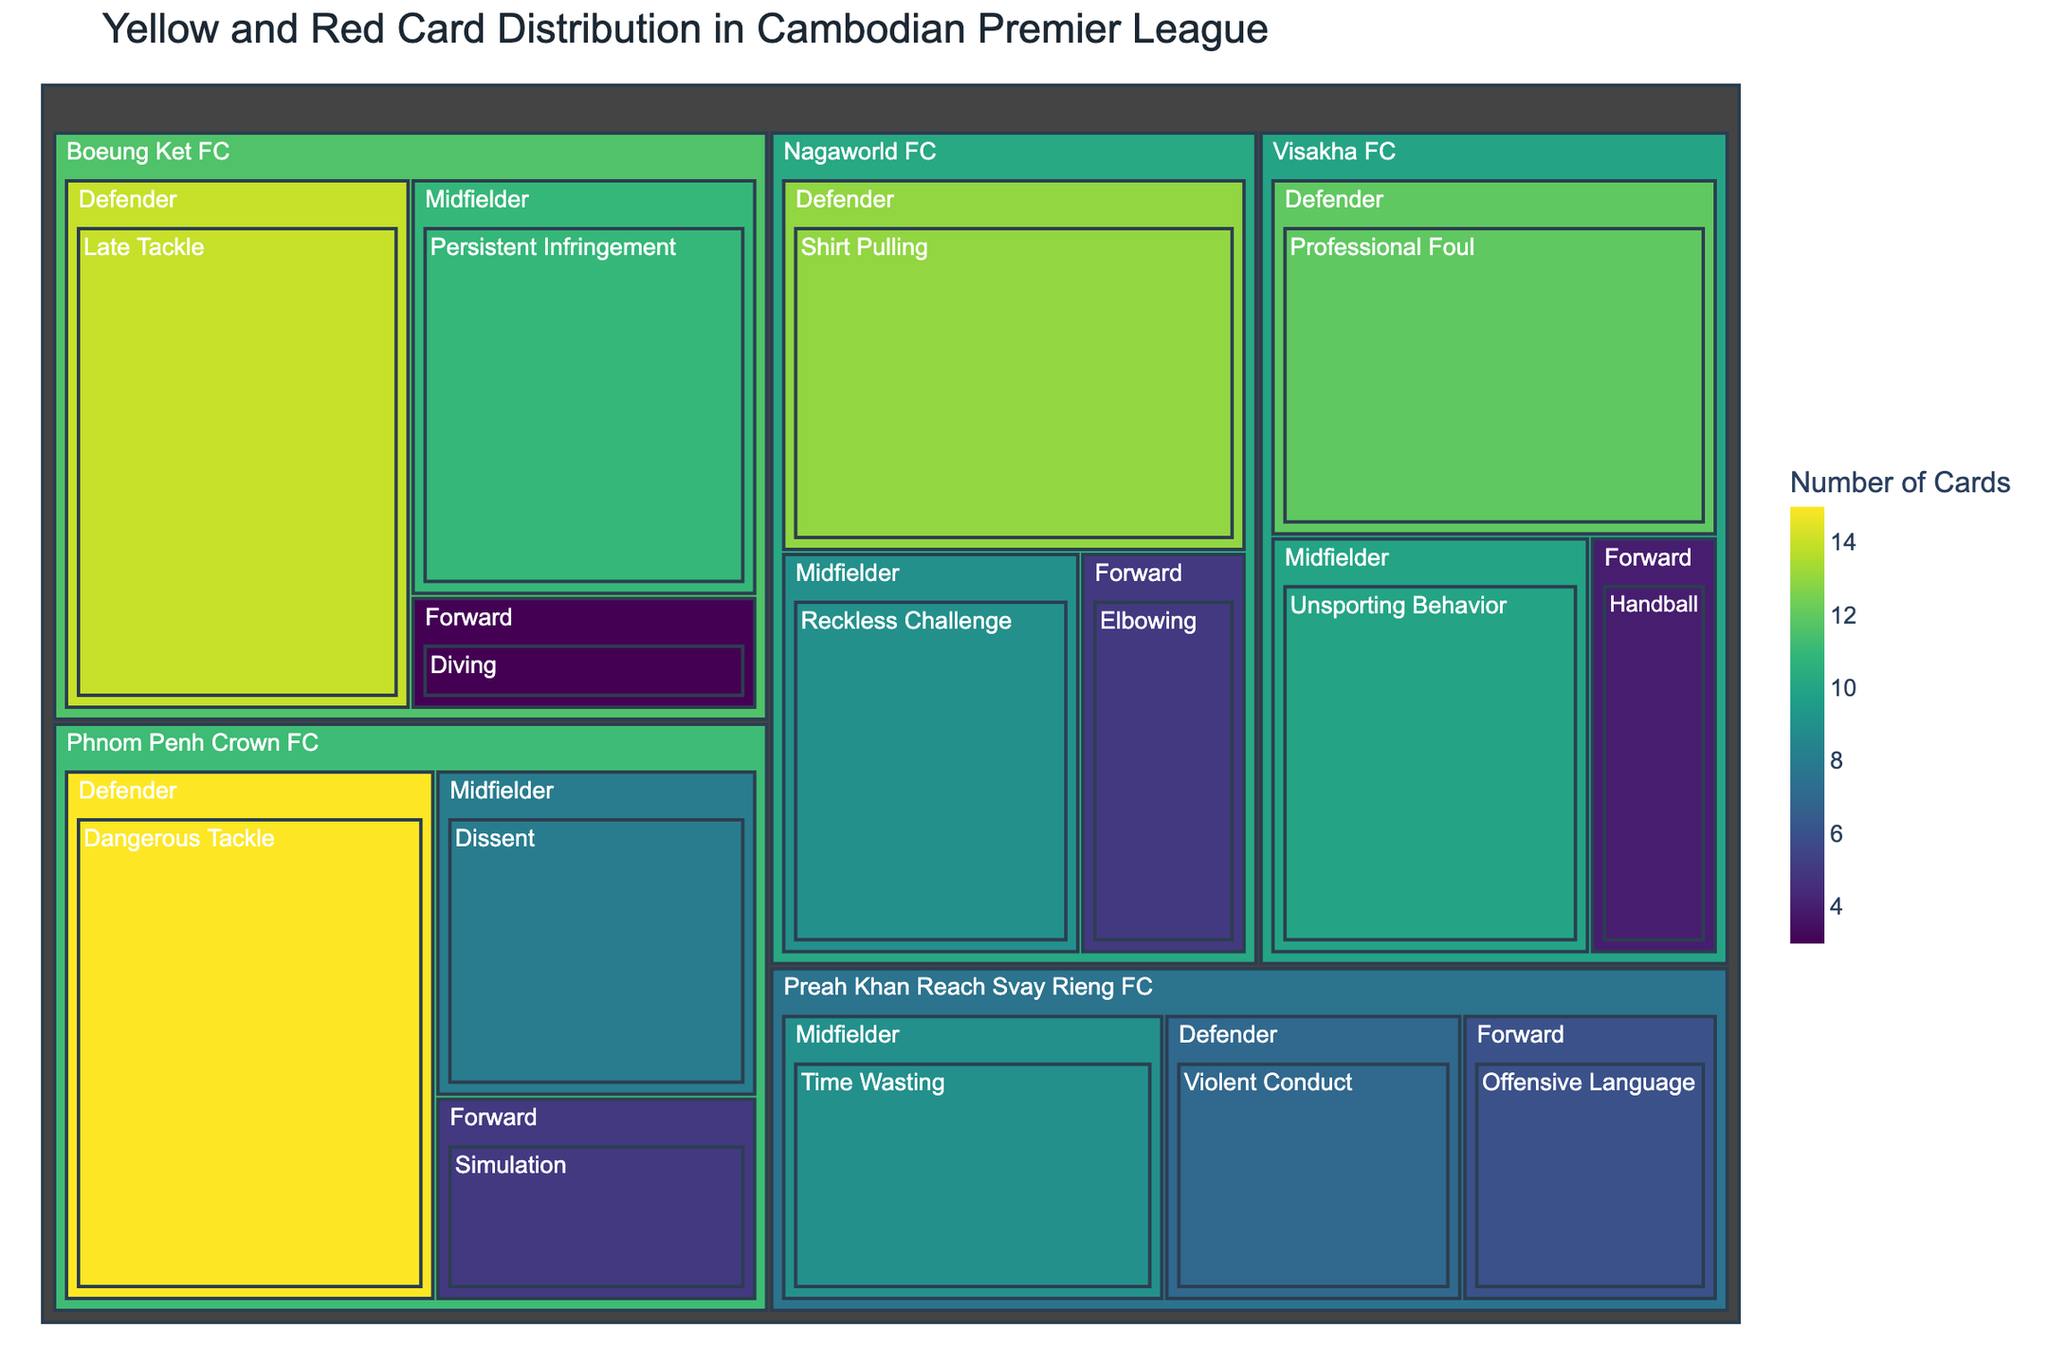What's the title of the figure? Look at the top of the treemap where the title is usually placed in bold or larger font.
Answer: Yellow and Red Card Distribution in Cambodian Premier League Which team has the highest number of cards for a single foul type? Identify the largest tile under each team's section and compare their sizes.
Answer: Phnom Penh Crown FC (Dangerous Tackle) How many cards were given to forwards for Phnom Penh Crown FC? Locate the section under Phnom Penh Crown FC for forwards and sum the values of the tiles.
Answer: 5 Which team has the least number of cards for handball? Examine each team's section to find any occurrence of handball and compare the values.
Answer: Visakha FC Compare the total number of cards for defenders versus midfielders in Boeung Ket FC. Add up the card values for defenders and midfielders under Boeung Ket FC.
Answer: Defenders: 14, Midfielders: 11 What is the average number of cards given to midfielders across all teams? Sum up all the cards given to midfielders and divide by the number of teams.
Answer: (8 + 10 + 9 + 11 + 9) / 5 = 47/5 = 9.4 Which foul type committed by defenders has the highest card count? Look under the defenders' category for each team and find the foul type with the largest card count.
Answer: Dangerous Tackle (15 cards) How do the total cards for dangerous tackles compare to those for dissent? Find the total card count for dangerous tackles and compare it with that for dissent.
Answer: Dangerous Tackle: 15, Dissent: 8 What's the combined number of cards for offensive language and handball? Find the values for offensive language and handball and add them together.
Answer: 6 (Offensive Language) + 4 (Handball) = 10 Which player position has the highest diversity in foul types? Check each player position under the different teams and count the unique foul types listed.
Answer: Midfielder 